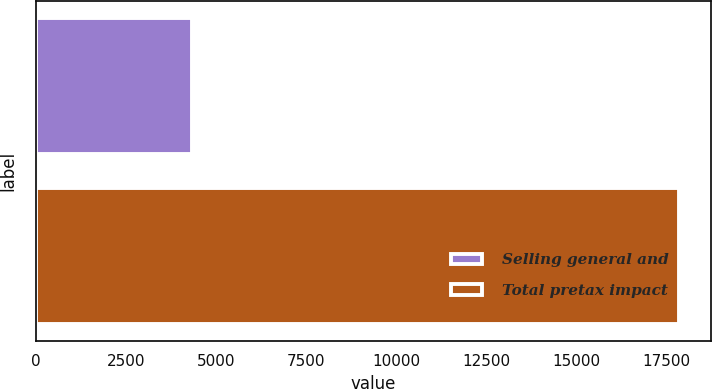Convert chart. <chart><loc_0><loc_0><loc_500><loc_500><bar_chart><fcel>Selling general and<fcel>Total pretax impact<nl><fcel>4325<fcel>17852<nl></chart> 